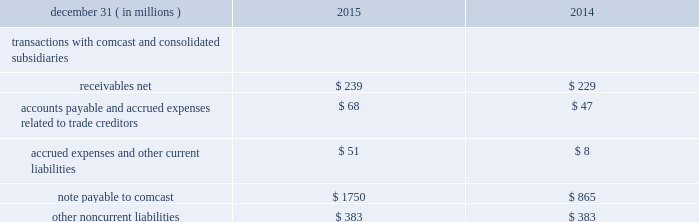Nbcuniversal media , llc following the close of the redemption transaction , comcast owns 96% ( 96 % ) of nbcuniversal holdings 2019 common units and nbcuniversal enterprise owns the remaining 4% ( 4 % ) .
Nbcuniversal enterprise is now a consolidated subsidiary of comcast , but we do not have any ownership interests in nbcuniversal enterprise .
Nbcuni- versal enterprise also owns all of nbcuniversal holdings 2019 preferred units with a $ 9.4 billion aggregate liquidation preference .
Nbcuniversal holdings is required to make quarterly payments to nbcuniversal enterprise at an initial rate of 8.25% ( 8.25 % ) per annum on the $ 9.4 billion aggregate liquidation preference of the preferred units .
On march 1 , 2018 , and thereafter on every fifth anniversary of such date , this rate will reset to 7.44% ( 7.44 % ) plus the yield on actively traded united states treasury securities having a 5 year maturity .
Nbcuni- versal holdings has the right to redeem all of the preferred units during the 30 day period beginning on march 1 , 2018 , and nbcuniversal enterprise has the right to cause nbcuniversal holdings to redeem 15% ( 15 % ) of its preferred units during the 30 day period beginning on march 19 , 2020 .
The price and units in a redemption initiated by either party will be based on the liquidation preference plus accrued but unpaid divi- dends and adjusted , in the case of an exercise of nbcuniversal enterprise 2019s right , to the extent the equity value of nbcuniversal holdings is less than the liquidation preference .
Our cash flows are , and will continue to be , the primary source of funding for the required payments and for any future redemption of the nbcuni- versal holdings preferred units .
Note 5 : related party transactions in the ordinary course of our business , we enter into transactions with comcast .
We generate revenue from comcast primarily from the distribution of our cable network programming and , to a lesser extent , the sale of advertising and our owned programming , and we incur expenses primarily related to advertising and various support services provided by comcast to us .
In 2013 , as part of the comcast cash management process , we and comcast entered into revolving credit agreements under which we can borrow up to $ 3 billion from comcast and comcast can borrow up to $ 3 bil- lion from us .
Amounts owed by us to comcast under the revolving credit agreement , including accrued interest , are presented under the caption 201cnote payable to comcast 201d in our consolidated balance sheet .
The revolving credit agreements bear interest at floating rates equal to the interest rate under the comcast and comcast cable communications , llc revolving credit facility ( the 201ccomcast revolving credit facility 201d ) .
The interest rate on the comcast revolving credit facility consists of a base rate plus a borrowing margin that is determined based on comcast 2019s credit rating .
As of december 31 , 2015 , the borrowing margin for london interbank offered rate-based borrowings was 1.00% ( 1.00 % ) .
In addition , comcast is the counterparty to one of our contractual obligations .
As of both december 31 , 2015 and 2014 , the carrying value of the liability associated with this contractual obligation was $ 383 million .
The tables present transactions with comcast and its consolidated subsidiaries that are included in our consolidated financial statements .
Consolidated balance sheet .
155 comcast 2015 annual report on form 10-k .
What was the change in the receivables net from 2014 to 2015 in millions? 
Computations: (239 / 229)
Answer: 1.04367. 